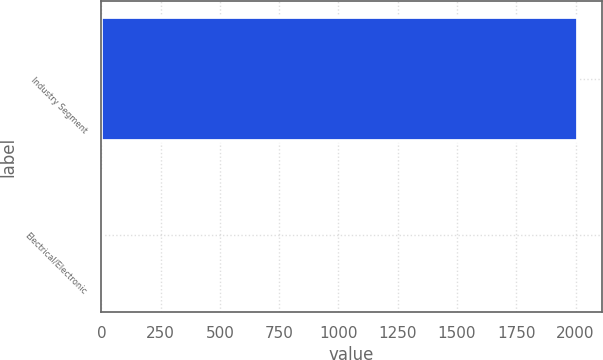<chart> <loc_0><loc_0><loc_500><loc_500><bar_chart><fcel>Industry Segment<fcel>Electrical/Electronic<nl><fcel>2010<fcel>4<nl></chart> 